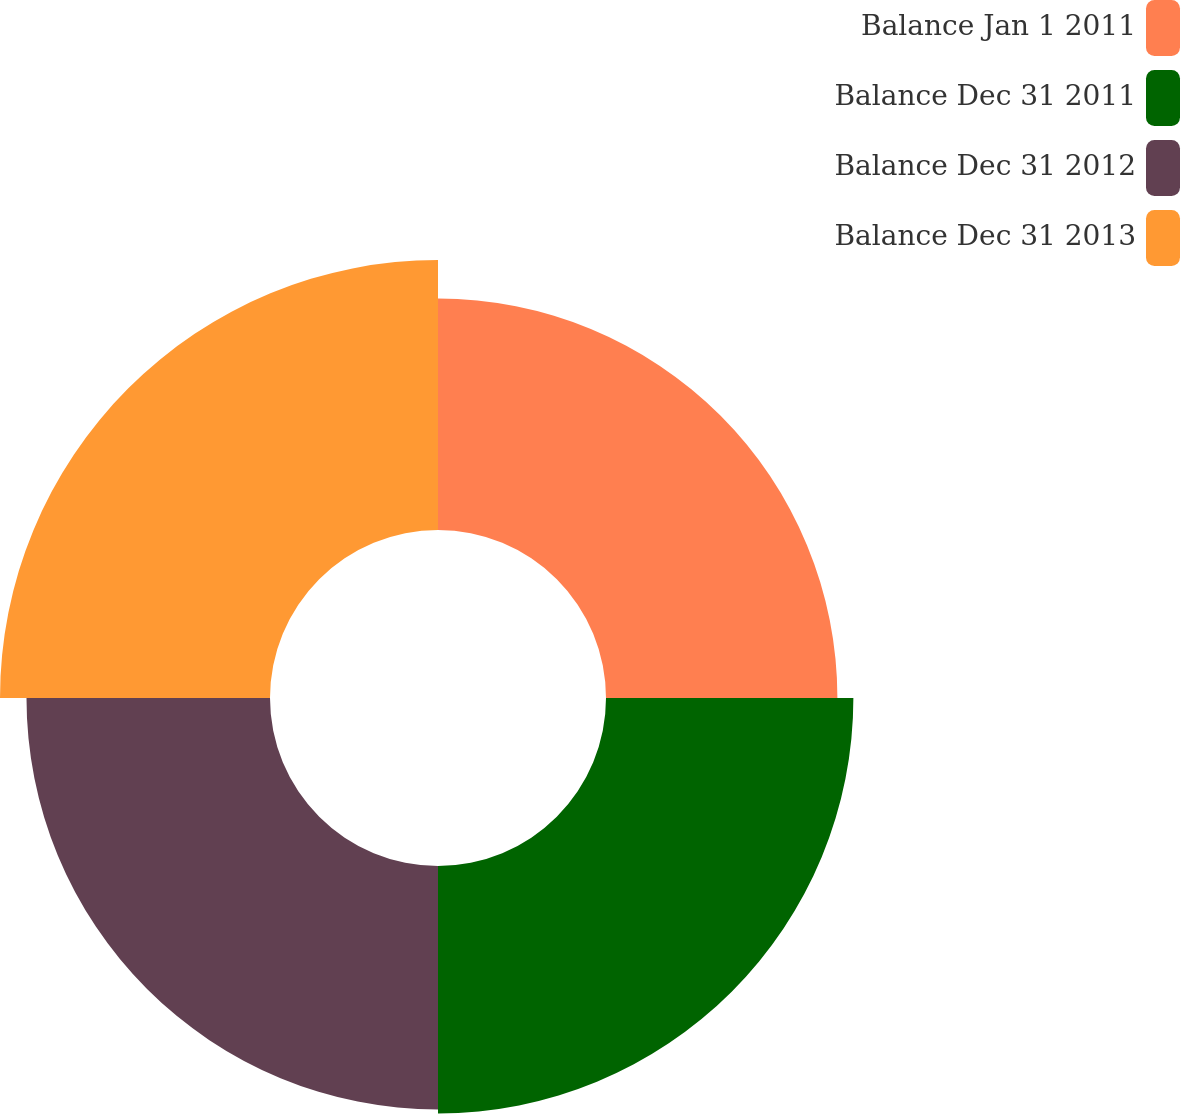Convert chart. <chart><loc_0><loc_0><loc_500><loc_500><pie_chart><fcel>Balance Jan 1 2011<fcel>Balance Dec 31 2011<fcel>Balance Dec 31 2012<fcel>Balance Dec 31 2013<nl><fcel>23.32%<fcel>24.93%<fcel>24.54%<fcel>27.21%<nl></chart> 